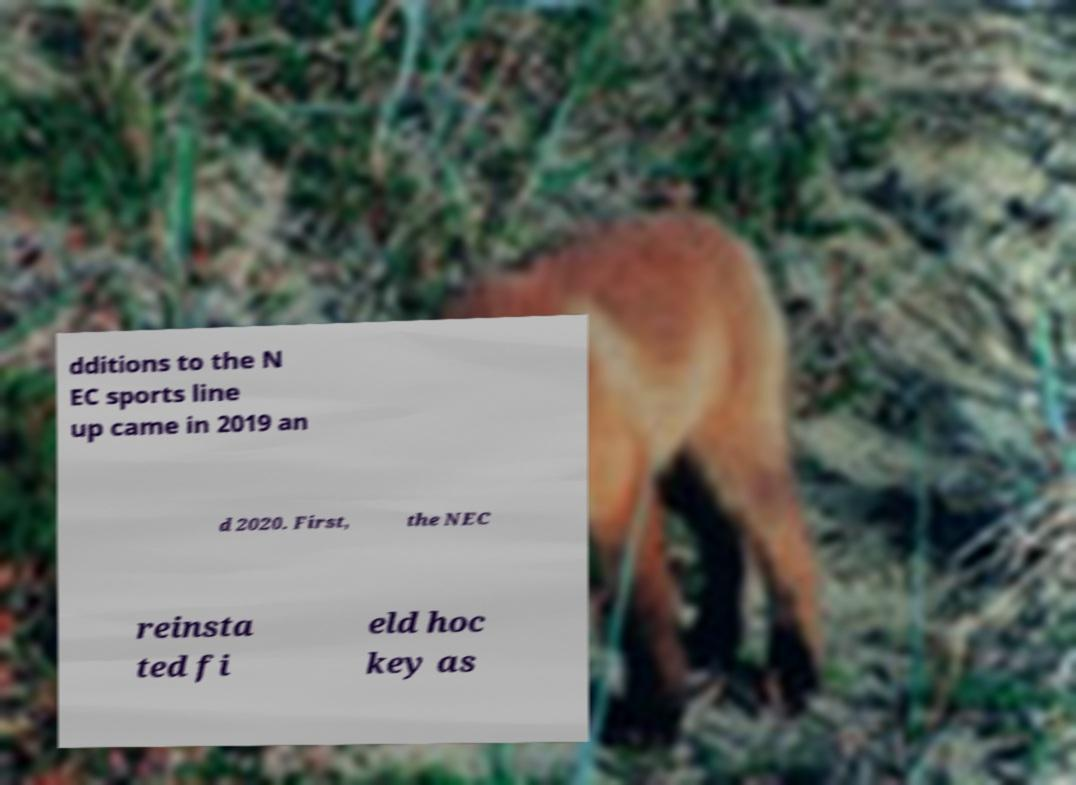Can you accurately transcribe the text from the provided image for me? dditions to the N EC sports line up came in 2019 an d 2020. First, the NEC reinsta ted fi eld hoc key as 